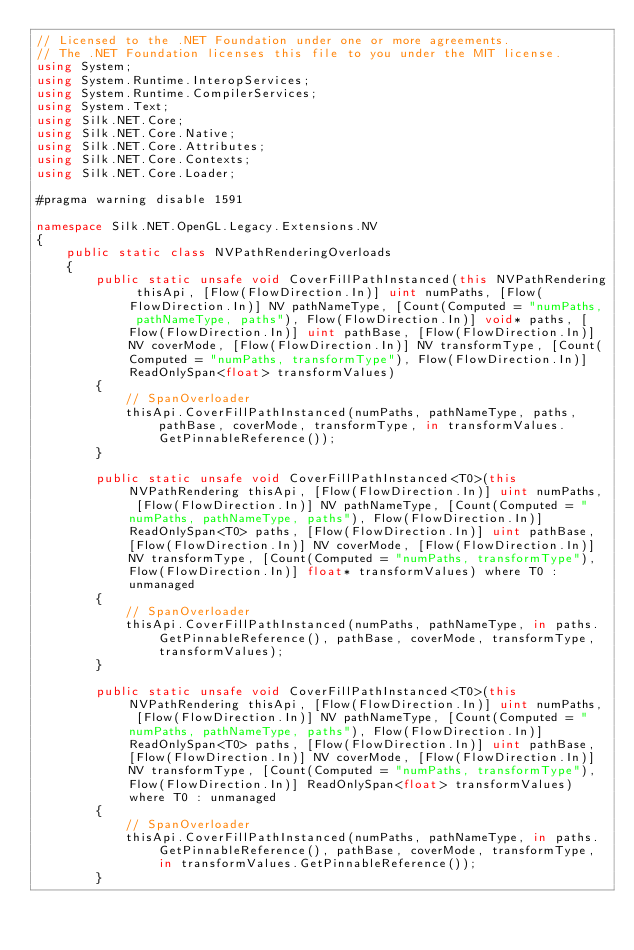Convert code to text. <code><loc_0><loc_0><loc_500><loc_500><_C#_>// Licensed to the .NET Foundation under one or more agreements.
// The .NET Foundation licenses this file to you under the MIT license.
using System;
using System.Runtime.InteropServices;
using System.Runtime.CompilerServices;
using System.Text;
using Silk.NET.Core;
using Silk.NET.Core.Native;
using Silk.NET.Core.Attributes;
using Silk.NET.Core.Contexts;
using Silk.NET.Core.Loader;

#pragma warning disable 1591

namespace Silk.NET.OpenGL.Legacy.Extensions.NV
{
    public static class NVPathRenderingOverloads
    {
        public static unsafe void CoverFillPathInstanced(this NVPathRendering thisApi, [Flow(FlowDirection.In)] uint numPaths, [Flow(FlowDirection.In)] NV pathNameType, [Count(Computed = "numPaths, pathNameType, paths"), Flow(FlowDirection.In)] void* paths, [Flow(FlowDirection.In)] uint pathBase, [Flow(FlowDirection.In)] NV coverMode, [Flow(FlowDirection.In)] NV transformType, [Count(Computed = "numPaths, transformType"), Flow(FlowDirection.In)] ReadOnlySpan<float> transformValues)
        {
            // SpanOverloader
            thisApi.CoverFillPathInstanced(numPaths, pathNameType, paths, pathBase, coverMode, transformType, in transformValues.GetPinnableReference());
        }

        public static unsafe void CoverFillPathInstanced<T0>(this NVPathRendering thisApi, [Flow(FlowDirection.In)] uint numPaths, [Flow(FlowDirection.In)] NV pathNameType, [Count(Computed = "numPaths, pathNameType, paths"), Flow(FlowDirection.In)] ReadOnlySpan<T0> paths, [Flow(FlowDirection.In)] uint pathBase, [Flow(FlowDirection.In)] NV coverMode, [Flow(FlowDirection.In)] NV transformType, [Count(Computed = "numPaths, transformType"), Flow(FlowDirection.In)] float* transformValues) where T0 : unmanaged
        {
            // SpanOverloader
            thisApi.CoverFillPathInstanced(numPaths, pathNameType, in paths.GetPinnableReference(), pathBase, coverMode, transformType, transformValues);
        }

        public static unsafe void CoverFillPathInstanced<T0>(this NVPathRendering thisApi, [Flow(FlowDirection.In)] uint numPaths, [Flow(FlowDirection.In)] NV pathNameType, [Count(Computed = "numPaths, pathNameType, paths"), Flow(FlowDirection.In)] ReadOnlySpan<T0> paths, [Flow(FlowDirection.In)] uint pathBase, [Flow(FlowDirection.In)] NV coverMode, [Flow(FlowDirection.In)] NV transformType, [Count(Computed = "numPaths, transformType"), Flow(FlowDirection.In)] ReadOnlySpan<float> transformValues) where T0 : unmanaged
        {
            // SpanOverloader
            thisApi.CoverFillPathInstanced(numPaths, pathNameType, in paths.GetPinnableReference(), pathBase, coverMode, transformType, in transformValues.GetPinnableReference());
        }
</code> 